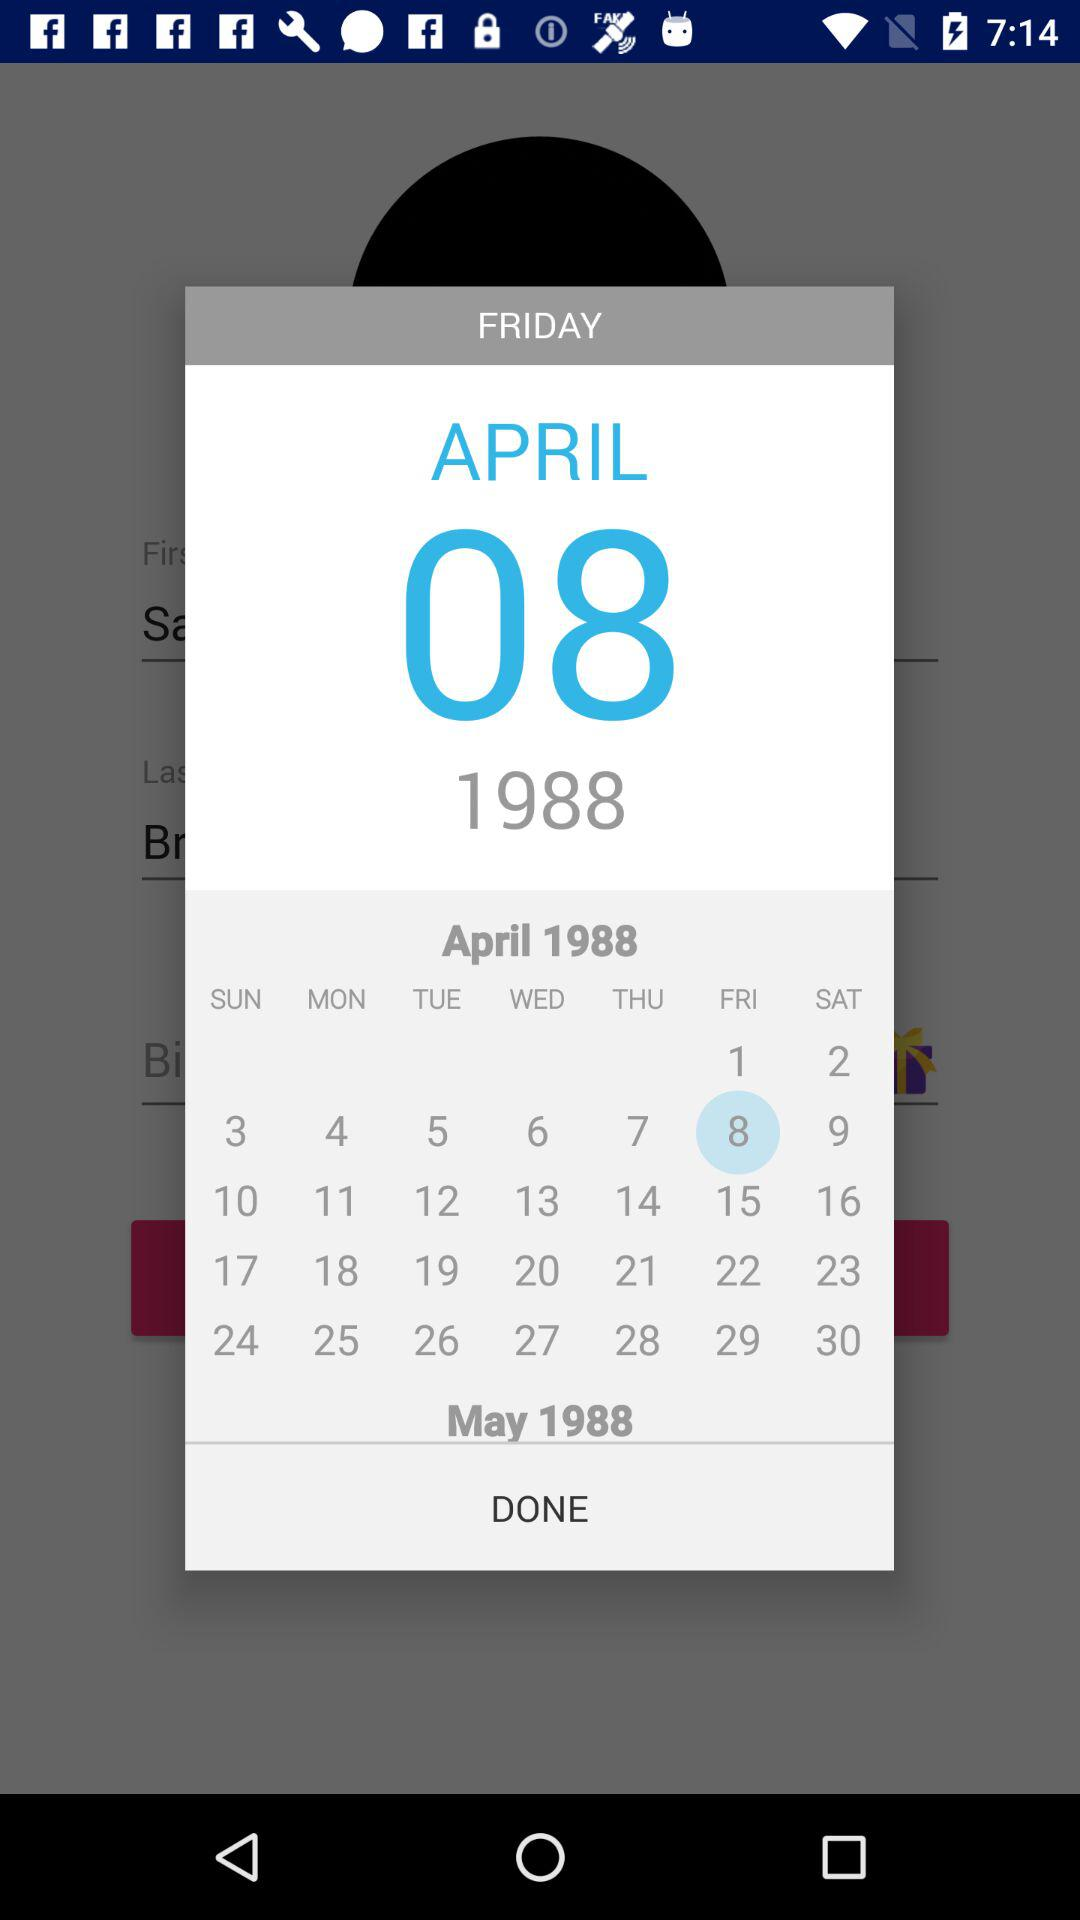What day is it on the selected date? The day is Friday. 